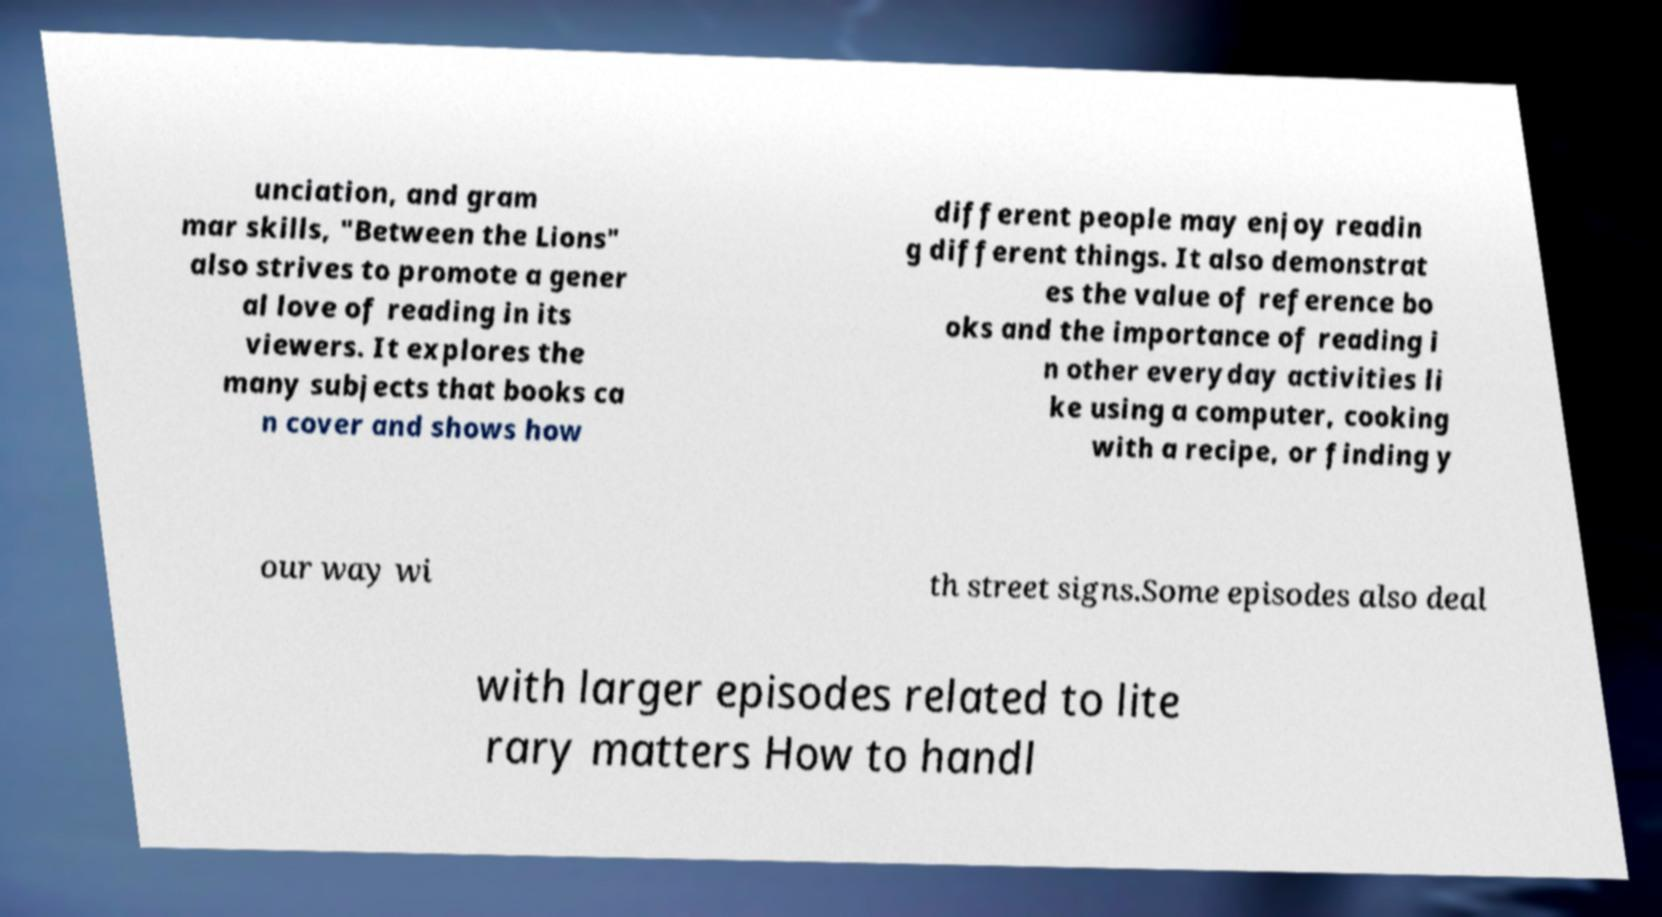Please identify and transcribe the text found in this image. unciation, and gram mar skills, "Between the Lions" also strives to promote a gener al love of reading in its viewers. It explores the many subjects that books ca n cover and shows how different people may enjoy readin g different things. It also demonstrat es the value of reference bo oks and the importance of reading i n other everyday activities li ke using a computer, cooking with a recipe, or finding y our way wi th street signs.Some episodes also deal with larger episodes related to lite rary matters How to handl 